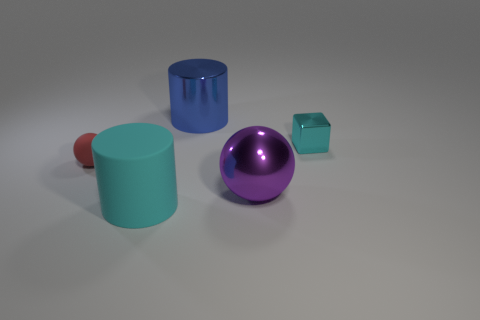Does the cylinder that is in front of the blue thing have the same color as the cube?
Provide a short and direct response. Yes. How many objects are large shiny objects right of the big blue cylinder or cyan rubber cylinders?
Provide a short and direct response. 2. There is a tiny shiny object; are there any red things to the right of it?
Your answer should be very brief. No. What material is the tiny block that is the same color as the big rubber thing?
Offer a terse response. Metal. Do the sphere left of the large shiny cylinder and the large blue object have the same material?
Keep it short and to the point. No. Are there any red matte objects that are in front of the big metallic thing behind the cyan object behind the big cyan cylinder?
Your response must be concise. Yes. What number of cylinders are either large cyan rubber things or big metal things?
Your response must be concise. 2. There is a tiny thing that is right of the blue thing; what is its material?
Give a very brief answer. Metal. What size is the shiny cube that is the same color as the large rubber cylinder?
Offer a very short reply. Small. There is a shiny thing that is right of the purple thing; is it the same color as the large cylinder that is in front of the tiny cyan object?
Offer a very short reply. Yes. 